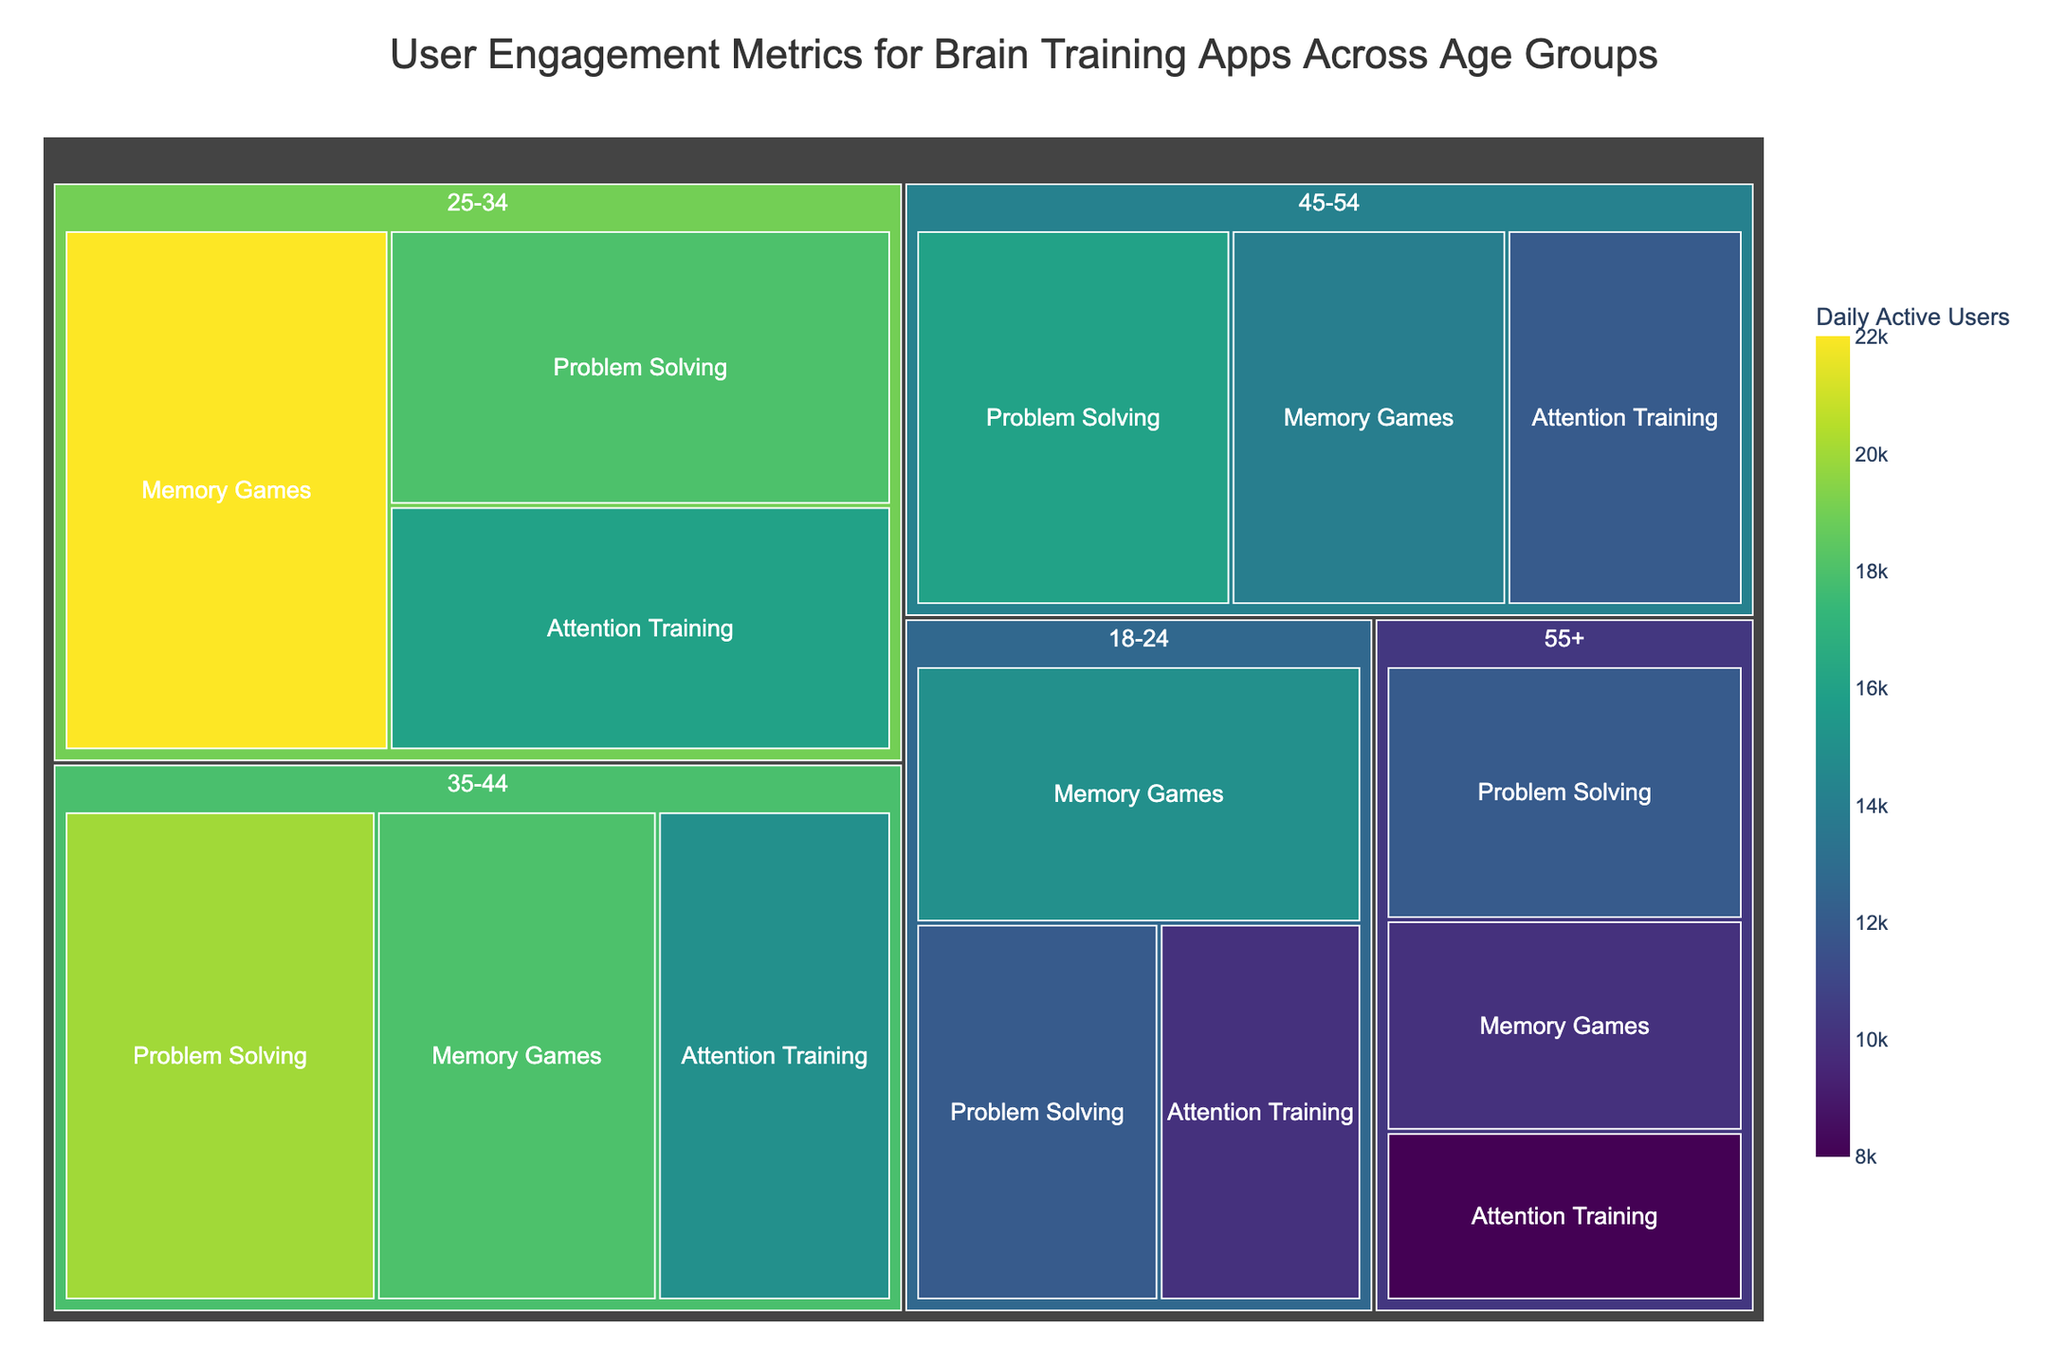How many age groups are represented in the Treemap? The treemap shows various sections based on age groups. By visually identifying these groups, we can determine their count.
Answer: 5 What's the title of the treemap? The title is usually displayed prominently at the top or near the top of the treemap.
Answer: User Engagement Metrics for Brain Training Apps Across Age Groups Which feature has the highest number of daily active users in the 25-34 age group? Look at the section for the 25-34 age group and compare the sizes of the blocks for Memory Games, Problem Solving, and Attention Training.
Answer: Memory Games How many daily active users engage with Problem Solving in the 45-54 age group? Check the section for 45-54 age group in the treemap and identify the number for the Problem Solving block.
Answer: 16,000 What is the difference in daily active users between Attention Training in the 18-24 age group and Memory Games in the 55+ age group? Identify the daily active users for both Attention Training in the 18-24 age group (10,000) and Memory Games in the 55+ age group (10,000). Calculate the difference between these two numbers.
Answer: 0 Which age group has the least number of daily active users for Attention Training? Review the sections for Attention Training across all age groups and identify the smallest number.
Answer: 55+ Compare the sum of daily active users for Problem Solving in the age groups 25-34 and 35-44. Identify the number of daily active users for Problem Solving in both 25-34 (18,000) and 35-44 (20,000), then add these numbers together.
Answer: 38,000 What is the total number of daily active users for Memory Games across all age groups? Add up the daily active users for Memory Games from all age groups: 18-24 (15,000), 25-34 (22,000), 35-44 (18,000), 45-54 (14,000), 55+ (10,000). Calculate the sum.
Answer: 79,000 In which age group does Problem Solving have more daily active users than Memory Games? Compare the numbers for Problem Solving and Memory Games within each age group to see where Problem Solving has a greater count.
Answer: 35-44 age group 